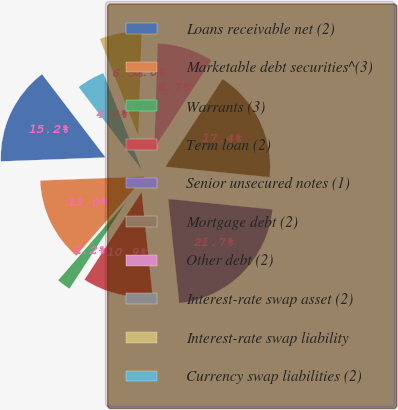Convert chart. <chart><loc_0><loc_0><loc_500><loc_500><pie_chart><fcel>Loans receivable net (2)<fcel>Marketable debt securities^(3)<fcel>Warrants (3)<fcel>Term loan (2)<fcel>Senior unsecured notes (1)<fcel>Mortgage debt (2)<fcel>Other debt (2)<fcel>Interest-rate swap asset (2)<fcel>Interest-rate swap liability<fcel>Currency swap liabilities (2)<nl><fcel>15.22%<fcel>13.04%<fcel>2.17%<fcel>10.87%<fcel>21.74%<fcel>17.39%<fcel>8.7%<fcel>0.0%<fcel>6.52%<fcel>4.35%<nl></chart> 